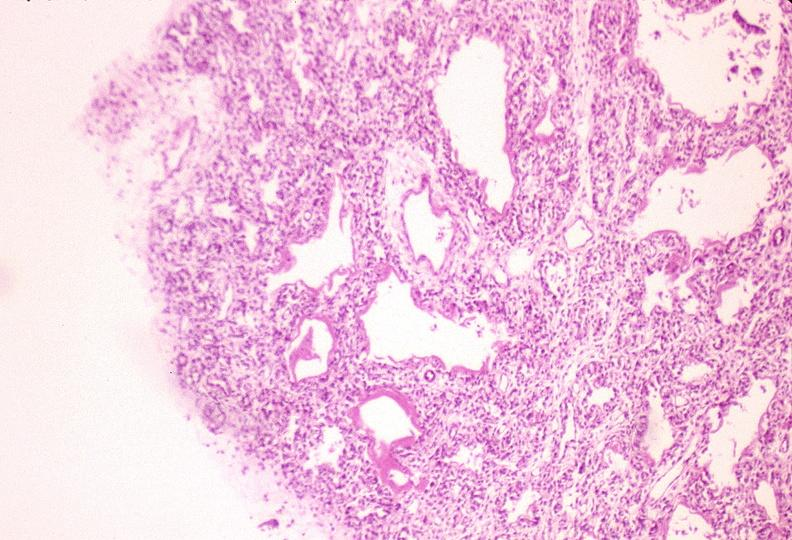s respiratory present?
Answer the question using a single word or phrase. Yes 